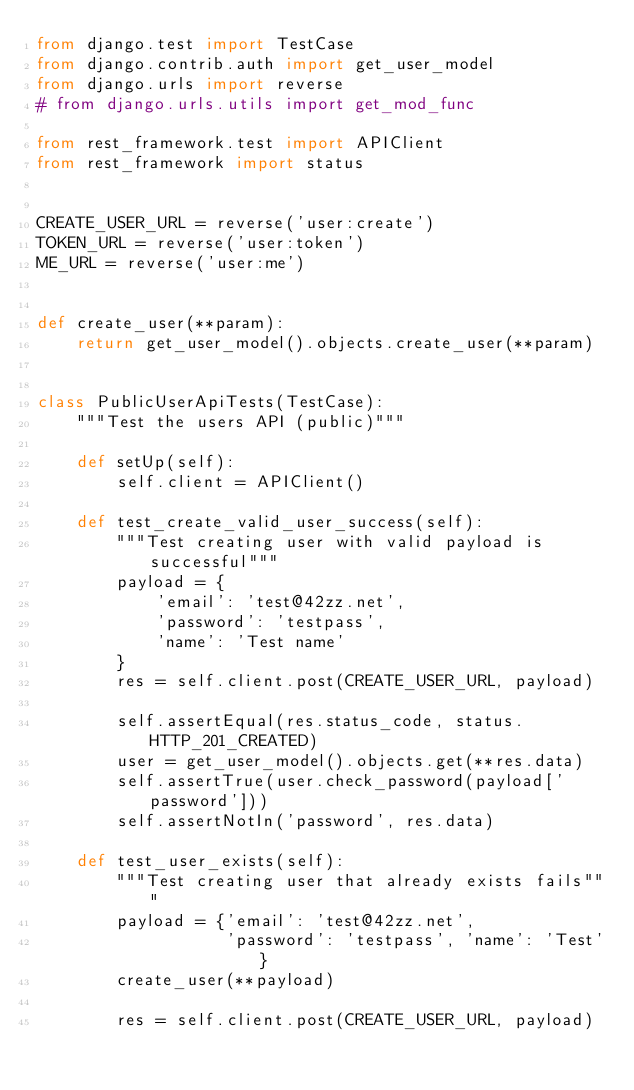Convert code to text. <code><loc_0><loc_0><loc_500><loc_500><_Python_>from django.test import TestCase
from django.contrib.auth import get_user_model
from django.urls import reverse
# from django.urls.utils import get_mod_func

from rest_framework.test import APIClient
from rest_framework import status


CREATE_USER_URL = reverse('user:create')
TOKEN_URL = reverse('user:token')
ME_URL = reverse('user:me')


def create_user(**param):
    return get_user_model().objects.create_user(**param)


class PublicUserApiTests(TestCase):
    """Test the users API (public)"""

    def setUp(self):
        self.client = APIClient()

    def test_create_valid_user_success(self):
        """Test creating user with valid payload is successful"""
        payload = {
            'email': 'test@42zz.net',
            'password': 'testpass',
            'name': 'Test name'
        }
        res = self.client.post(CREATE_USER_URL, payload)

        self.assertEqual(res.status_code, status.HTTP_201_CREATED)
        user = get_user_model().objects.get(**res.data)
        self.assertTrue(user.check_password(payload['password']))
        self.assertNotIn('password', res.data)

    def test_user_exists(self):
        """Test creating user that already exists fails"""
        payload = {'email': 'test@42zz.net',
                   'password': 'testpass', 'name': 'Test'}
        create_user(**payload)

        res = self.client.post(CREATE_USER_URL, payload)
</code> 